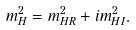<formula> <loc_0><loc_0><loc_500><loc_500>m _ { H } ^ { 2 } = m _ { H R } ^ { 2 } + i m _ { H I } ^ { 2 } .</formula> 